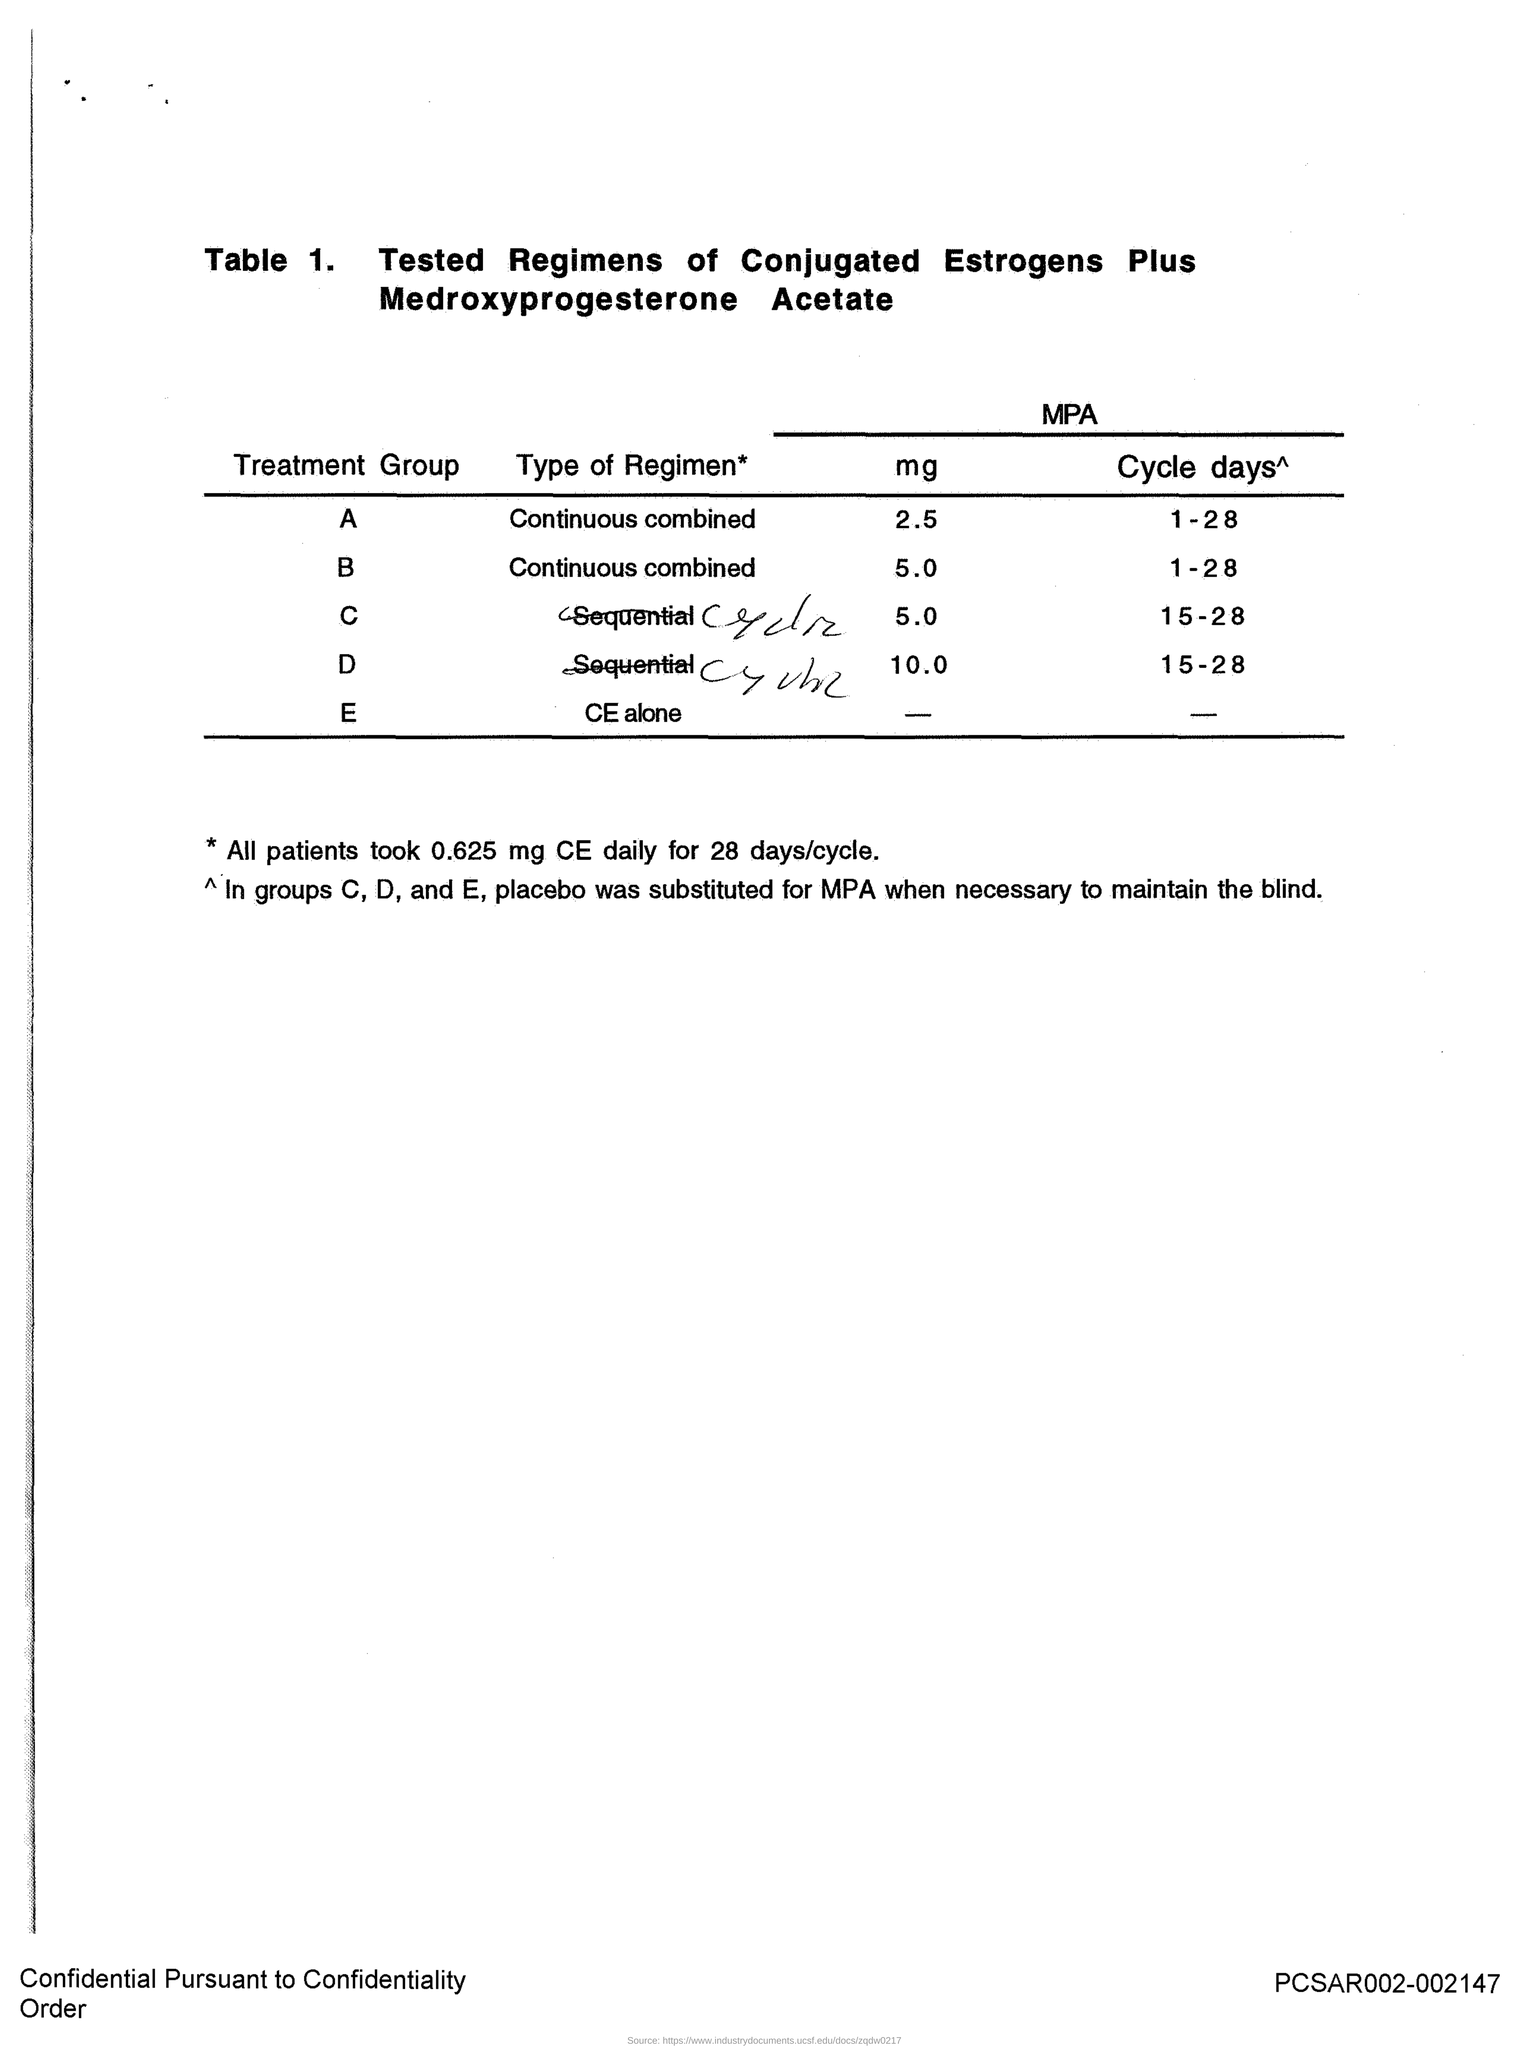Draw attention to some important aspects in this diagram. The daily dose taken by all patients for 28 days is 0.625 mg. The title of Table 1 is 'Tested Regimens of Conjugated Estrogens Plus Medroxyprogesterone Acetate.' 